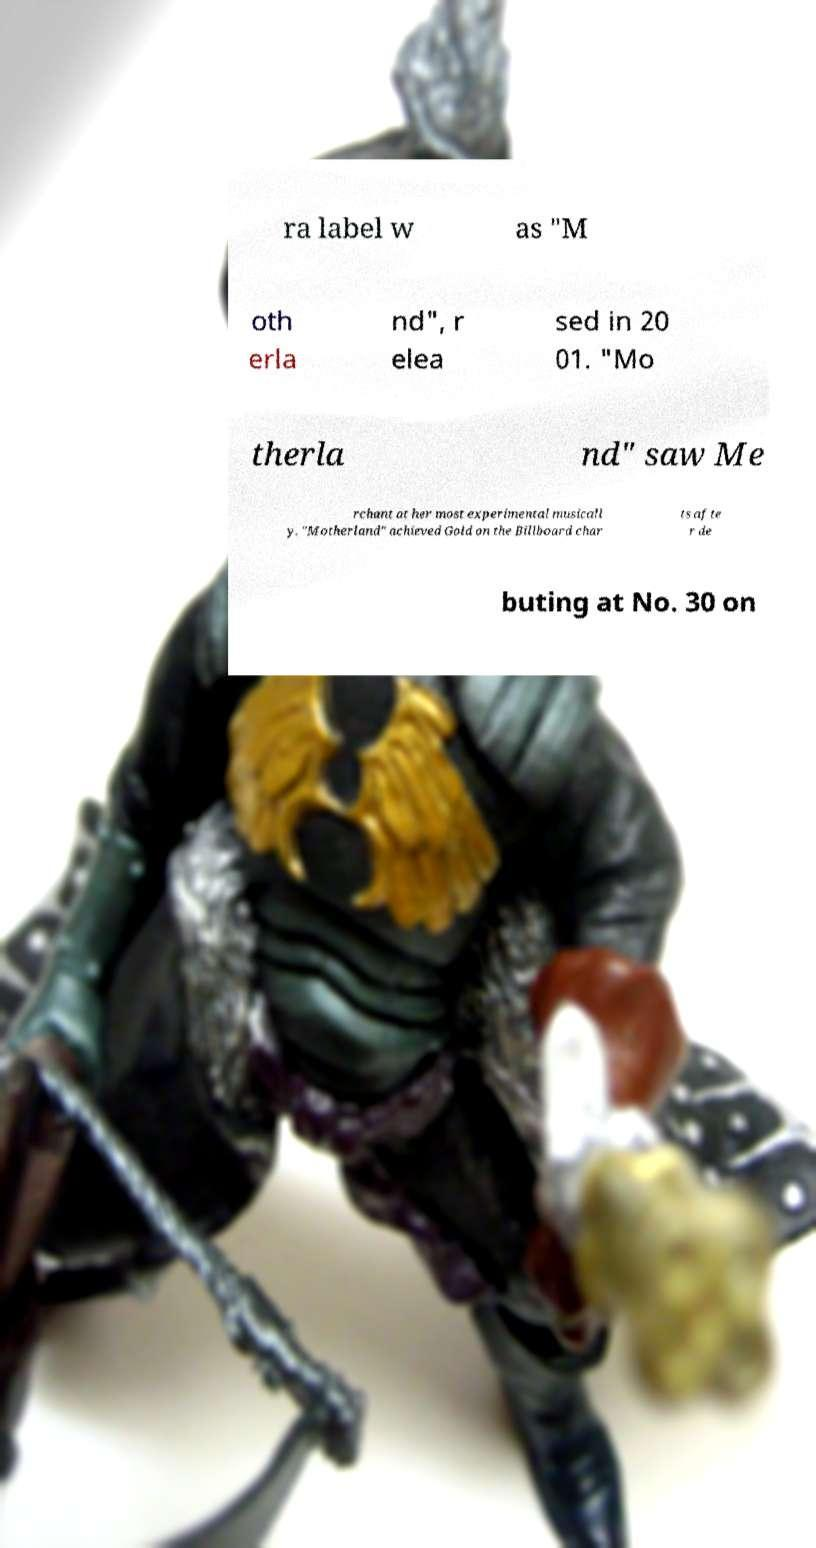For documentation purposes, I need the text within this image transcribed. Could you provide that? ra label w as "M oth erla nd", r elea sed in 20 01. "Mo therla nd" saw Me rchant at her most experimental musicall y. "Motherland" achieved Gold on the Billboard char ts afte r de buting at No. 30 on 